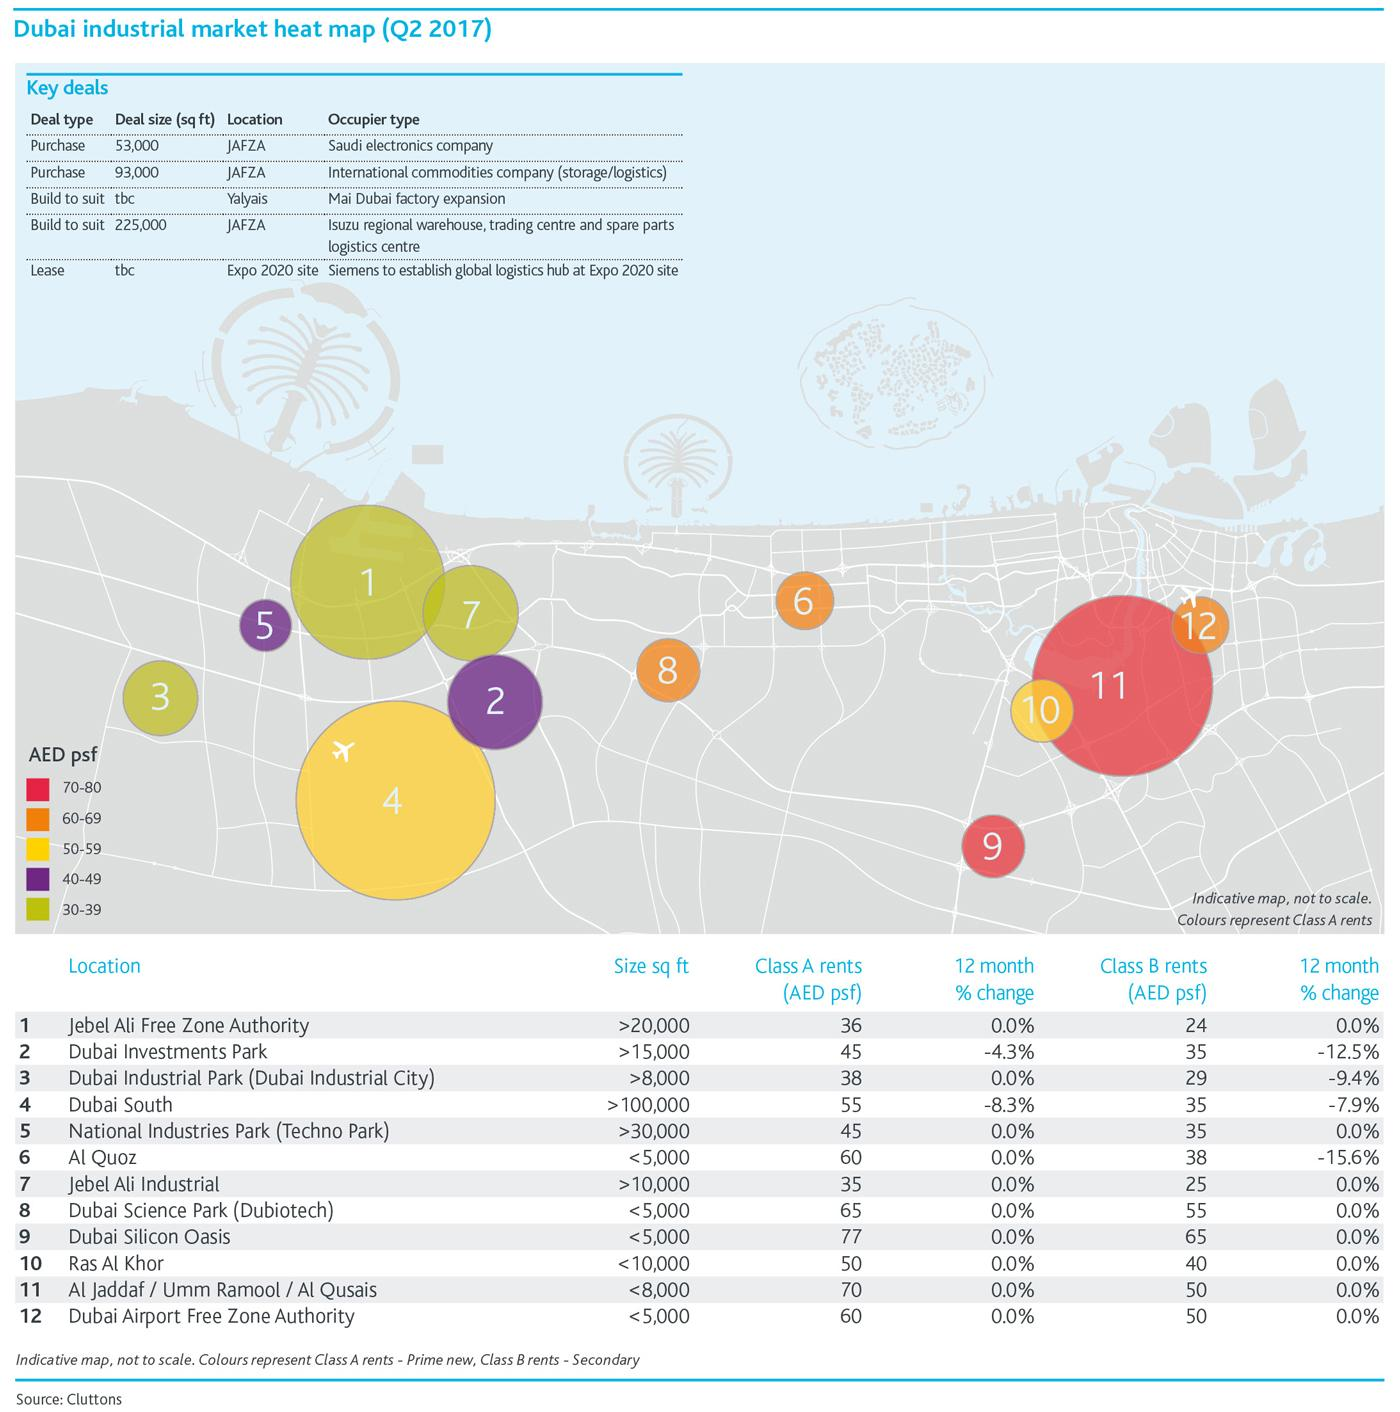Mention a couple of crucial points in this snapshot. The second item in the third row of the table labeled 'Key Deals' is currently unknown. The Class A rental prices are in the range of 70-80 in several locations, including Dubai Silicon Oasis, Al Jadaff, Umm Ramool, and Al Qusais. There are two locations with Class A rents in the range of 50-59. The difference between the Class A rent and the Class B rent in Al Quoz is 22.. The difference between the Class A rent and B rent of Dubai South is approximately 20 percent. 